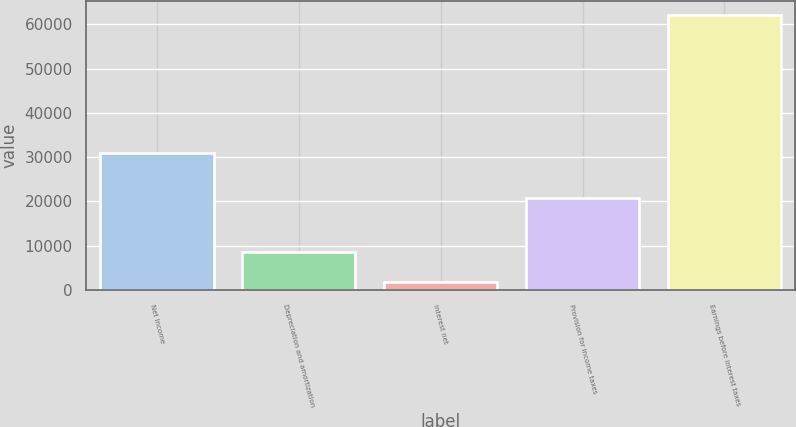<chart> <loc_0><loc_0><loc_500><loc_500><bar_chart><fcel>Net income<fcel>Depreciation and amortization<fcel>Interest net<fcel>Provision for income taxes<fcel>Earnings before interest taxes<nl><fcel>30887<fcel>8574<fcel>1887<fcel>20796<fcel>62144<nl></chart> 